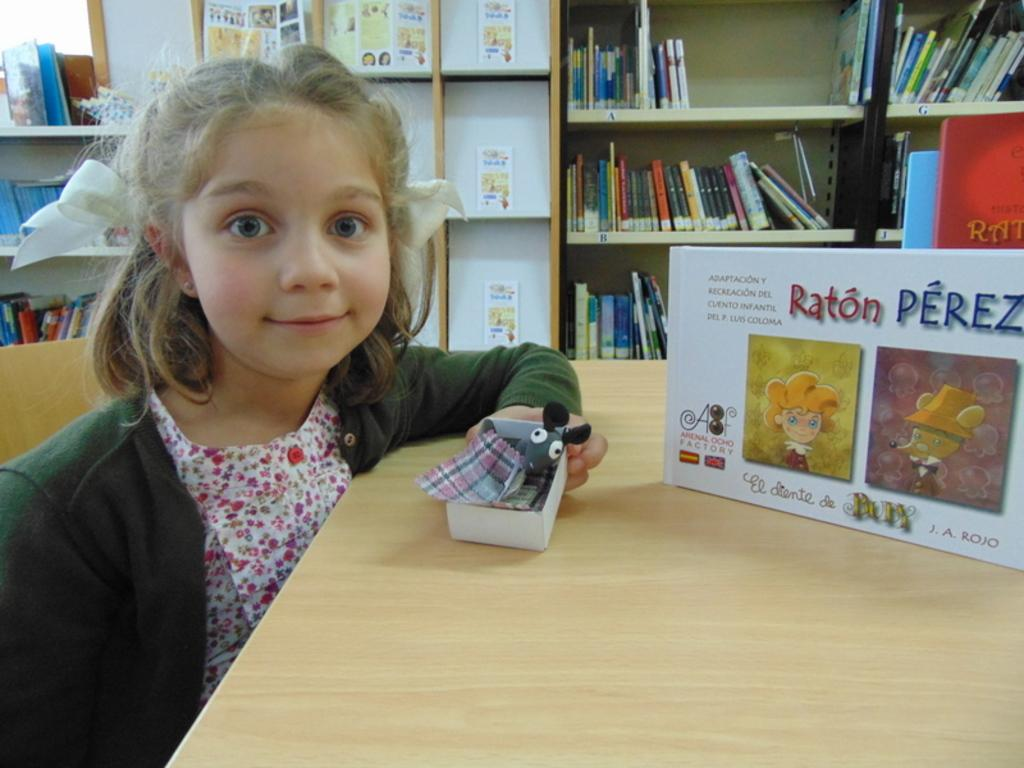<image>
Share a concise interpretation of the image provided. a girl sitting at a table with a book called "Ratón Pérez" 